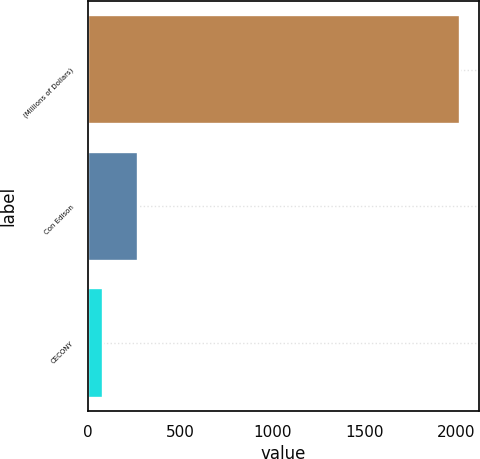<chart> <loc_0><loc_0><loc_500><loc_500><bar_chart><fcel>(Millions of Dollars)<fcel>Con Edison<fcel>CECONY<nl><fcel>2019<fcel>273<fcel>79<nl></chart> 